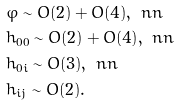Convert formula to latex. <formula><loc_0><loc_0><loc_500><loc_500>& \varphi \sim O ( 2 ) + O ( 4 ) , \ n n \\ & h _ { 0 0 } \sim O ( 2 ) + O ( 4 ) , \ n n \\ & h _ { 0 i } \sim O ( 3 ) , \ n n \\ & h _ { i j } \sim O ( 2 ) .</formula> 